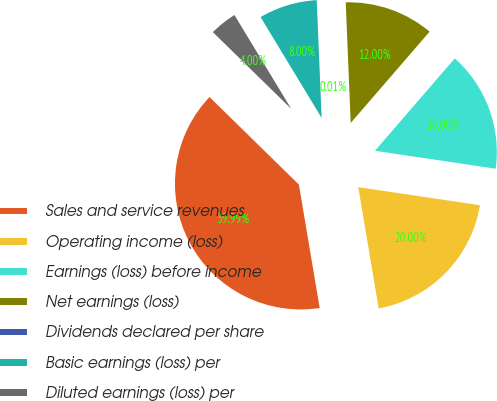<chart> <loc_0><loc_0><loc_500><loc_500><pie_chart><fcel>Sales and service revenues<fcel>Operating income (loss)<fcel>Earnings (loss) before income<fcel>Net earnings (loss)<fcel>Dividends declared per share<fcel>Basic earnings (loss) per<fcel>Diluted earnings (loss) per<nl><fcel>39.99%<fcel>20.0%<fcel>16.0%<fcel>12.0%<fcel>0.01%<fcel>8.0%<fcel>4.0%<nl></chart> 